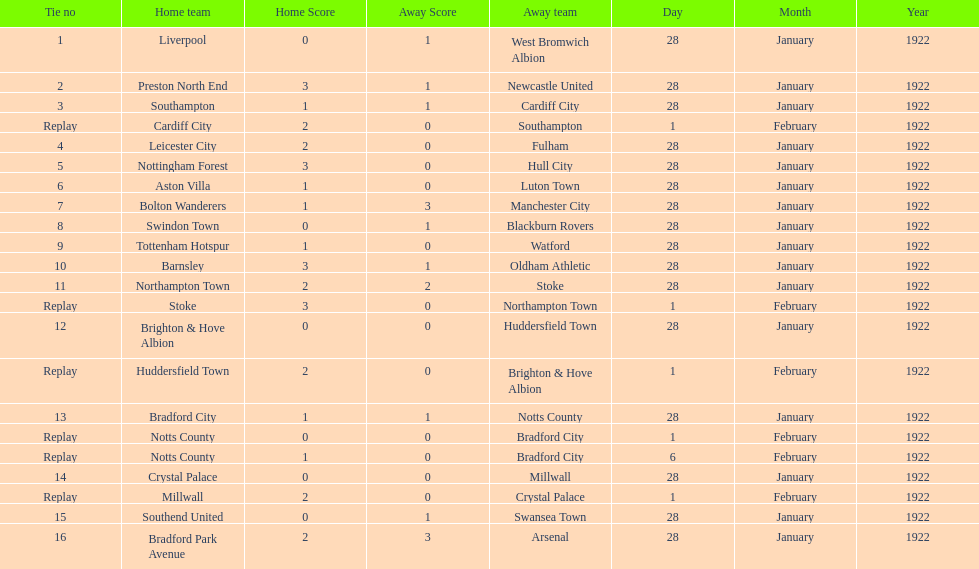How many total points were scored in the second round proper? 45. 